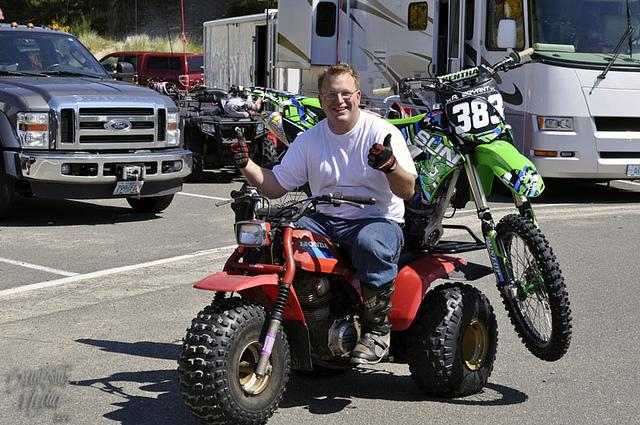Why does he have a bike on the back of his vehicle? broken 